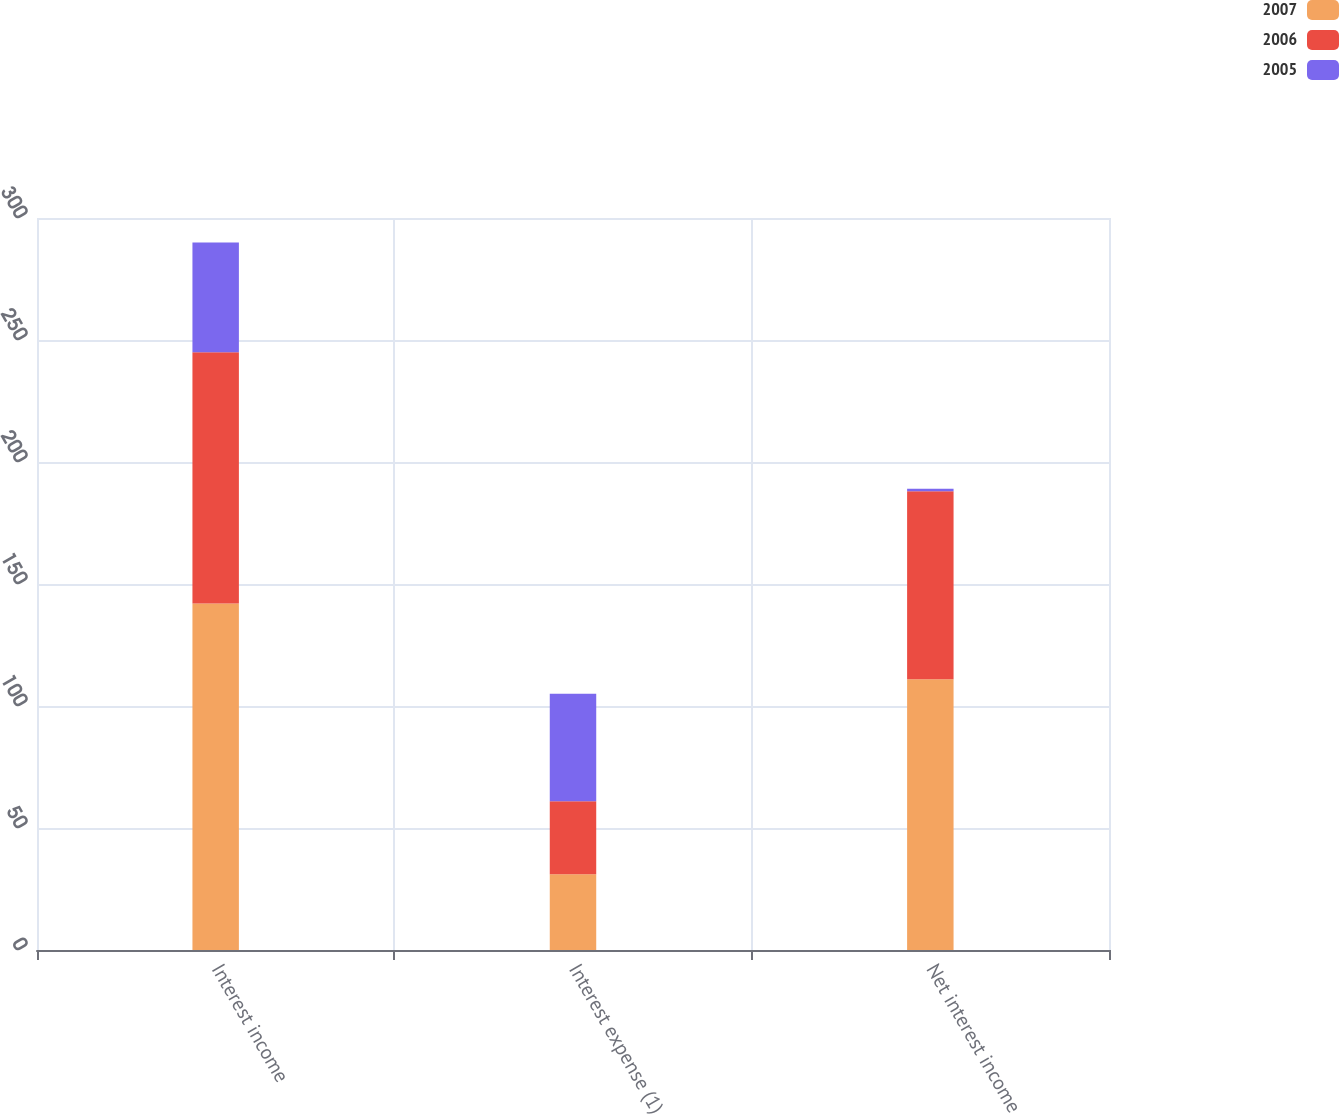Convert chart to OTSL. <chart><loc_0><loc_0><loc_500><loc_500><stacked_bar_chart><ecel><fcel>Interest income<fcel>Interest expense (1)<fcel>Net interest income<nl><fcel>2007<fcel>142<fcel>31<fcel>111<nl><fcel>2006<fcel>103<fcel>30<fcel>77<nl><fcel>2005<fcel>45<fcel>44<fcel>1<nl></chart> 